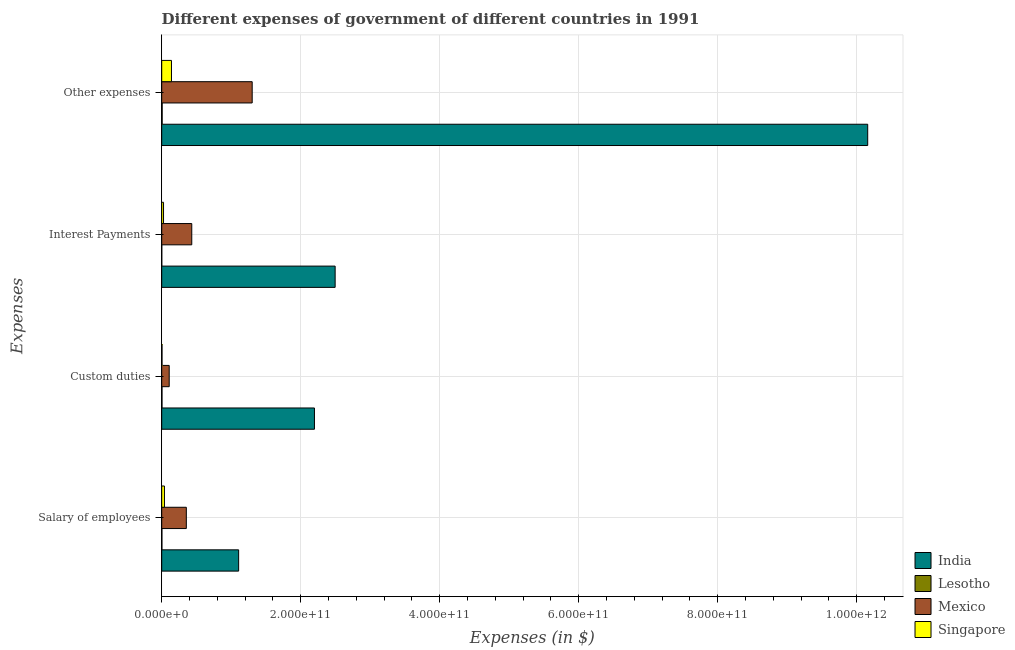How many different coloured bars are there?
Your answer should be compact. 4. How many groups of bars are there?
Your answer should be very brief. 4. Are the number of bars on each tick of the Y-axis equal?
Keep it short and to the point. Yes. What is the label of the 3rd group of bars from the top?
Offer a very short reply. Custom duties. What is the amount spent on other expenses in Singapore?
Provide a succinct answer. 1.40e+1. Across all countries, what is the maximum amount spent on custom duties?
Provide a succinct answer. 2.20e+11. Across all countries, what is the minimum amount spent on salary of employees?
Offer a terse response. 2.81e+08. In which country was the amount spent on other expenses maximum?
Your response must be concise. India. In which country was the amount spent on custom duties minimum?
Make the answer very short. Lesotho. What is the total amount spent on custom duties in the graph?
Make the answer very short. 2.31e+11. What is the difference between the amount spent on interest payments in Singapore and that in Mexico?
Make the answer very short. -4.06e+1. What is the difference between the amount spent on custom duties in India and the amount spent on other expenses in Lesotho?
Offer a very short reply. 2.19e+11. What is the average amount spent on custom duties per country?
Make the answer very short. 5.79e+1. What is the difference between the amount spent on other expenses and amount spent on salary of employees in Lesotho?
Give a very brief answer. 3.55e+08. What is the ratio of the amount spent on interest payments in India to that in Singapore?
Make the answer very short. 94.92. Is the amount spent on other expenses in Mexico less than that in Singapore?
Your response must be concise. No. What is the difference between the highest and the second highest amount spent on interest payments?
Your response must be concise. 2.06e+11. What is the difference between the highest and the lowest amount spent on other expenses?
Make the answer very short. 1.02e+12. Is it the case that in every country, the sum of the amount spent on other expenses and amount spent on custom duties is greater than the sum of amount spent on salary of employees and amount spent on interest payments?
Ensure brevity in your answer.  No. What does the 2nd bar from the top in Custom duties represents?
Offer a terse response. Mexico. What does the 2nd bar from the bottom in Salary of employees represents?
Offer a terse response. Lesotho. What is the difference between two consecutive major ticks on the X-axis?
Your response must be concise. 2.00e+11. Does the graph contain grids?
Provide a short and direct response. Yes. How are the legend labels stacked?
Provide a succinct answer. Vertical. What is the title of the graph?
Keep it short and to the point. Different expenses of government of different countries in 1991. What is the label or title of the X-axis?
Offer a very short reply. Expenses (in $). What is the label or title of the Y-axis?
Your answer should be compact. Expenses. What is the Expenses (in $) of India in Salary of employees?
Keep it short and to the point. 1.11e+11. What is the Expenses (in $) in Lesotho in Salary of employees?
Provide a succinct answer. 2.81e+08. What is the Expenses (in $) in Mexico in Salary of employees?
Your answer should be very brief. 3.54e+1. What is the Expenses (in $) in Singapore in Salary of employees?
Give a very brief answer. 3.95e+09. What is the Expenses (in $) in India in Custom duties?
Your answer should be very brief. 2.20e+11. What is the Expenses (in $) in Lesotho in Custom duties?
Provide a succinct answer. 4.24e+08. What is the Expenses (in $) of Mexico in Custom duties?
Your response must be concise. 1.08e+1. What is the Expenses (in $) in Singapore in Custom duties?
Provide a short and direct response. 4.33e+08. What is the Expenses (in $) of India in Interest Payments?
Provide a succinct answer. 2.50e+11. What is the Expenses (in $) of Lesotho in Interest Payments?
Give a very brief answer. 8.45e+07. What is the Expenses (in $) in Mexico in Interest Payments?
Ensure brevity in your answer.  4.32e+1. What is the Expenses (in $) in Singapore in Interest Payments?
Keep it short and to the point. 2.63e+09. What is the Expenses (in $) of India in Other expenses?
Your answer should be very brief. 1.02e+12. What is the Expenses (in $) in Lesotho in Other expenses?
Provide a succinct answer. 6.37e+08. What is the Expenses (in $) in Mexico in Other expenses?
Make the answer very short. 1.30e+11. What is the Expenses (in $) in Singapore in Other expenses?
Make the answer very short. 1.40e+1. Across all Expenses, what is the maximum Expenses (in $) of India?
Provide a succinct answer. 1.02e+12. Across all Expenses, what is the maximum Expenses (in $) of Lesotho?
Your answer should be compact. 6.37e+08. Across all Expenses, what is the maximum Expenses (in $) in Mexico?
Your response must be concise. 1.30e+11. Across all Expenses, what is the maximum Expenses (in $) of Singapore?
Ensure brevity in your answer.  1.40e+1. Across all Expenses, what is the minimum Expenses (in $) of India?
Offer a terse response. 1.11e+11. Across all Expenses, what is the minimum Expenses (in $) in Lesotho?
Offer a terse response. 8.45e+07. Across all Expenses, what is the minimum Expenses (in $) in Mexico?
Ensure brevity in your answer.  1.08e+1. Across all Expenses, what is the minimum Expenses (in $) of Singapore?
Make the answer very short. 4.33e+08. What is the total Expenses (in $) of India in the graph?
Offer a terse response. 1.60e+12. What is the total Expenses (in $) of Lesotho in the graph?
Offer a terse response. 1.43e+09. What is the total Expenses (in $) in Mexico in the graph?
Offer a terse response. 2.20e+11. What is the total Expenses (in $) of Singapore in the graph?
Keep it short and to the point. 2.11e+1. What is the difference between the Expenses (in $) of India in Salary of employees and that in Custom duties?
Keep it short and to the point. -1.09e+11. What is the difference between the Expenses (in $) of Lesotho in Salary of employees and that in Custom duties?
Your response must be concise. -1.43e+08. What is the difference between the Expenses (in $) in Mexico in Salary of employees and that in Custom duties?
Offer a terse response. 2.46e+1. What is the difference between the Expenses (in $) in Singapore in Salary of employees and that in Custom duties?
Ensure brevity in your answer.  3.52e+09. What is the difference between the Expenses (in $) of India in Salary of employees and that in Interest Payments?
Offer a terse response. -1.39e+11. What is the difference between the Expenses (in $) in Lesotho in Salary of employees and that in Interest Payments?
Offer a terse response. 1.97e+08. What is the difference between the Expenses (in $) of Mexico in Salary of employees and that in Interest Payments?
Make the answer very short. -7.83e+09. What is the difference between the Expenses (in $) of Singapore in Salary of employees and that in Interest Payments?
Your response must be concise. 1.32e+09. What is the difference between the Expenses (in $) in India in Salary of employees and that in Other expenses?
Your answer should be compact. -9.05e+11. What is the difference between the Expenses (in $) of Lesotho in Salary of employees and that in Other expenses?
Provide a succinct answer. -3.55e+08. What is the difference between the Expenses (in $) of Mexico in Salary of employees and that in Other expenses?
Provide a short and direct response. -9.48e+1. What is the difference between the Expenses (in $) of Singapore in Salary of employees and that in Other expenses?
Your answer should be compact. -1.01e+1. What is the difference between the Expenses (in $) in India in Custom duties and that in Interest Payments?
Ensure brevity in your answer.  -2.98e+1. What is the difference between the Expenses (in $) in Lesotho in Custom duties and that in Interest Payments?
Provide a succinct answer. 3.40e+08. What is the difference between the Expenses (in $) of Mexico in Custom duties and that in Interest Payments?
Provide a succinct answer. -3.25e+1. What is the difference between the Expenses (in $) in Singapore in Custom duties and that in Interest Payments?
Ensure brevity in your answer.  -2.20e+09. What is the difference between the Expenses (in $) in India in Custom duties and that in Other expenses?
Your response must be concise. -7.96e+11. What is the difference between the Expenses (in $) in Lesotho in Custom duties and that in Other expenses?
Your answer should be compact. -2.13e+08. What is the difference between the Expenses (in $) of Mexico in Custom duties and that in Other expenses?
Provide a short and direct response. -1.19e+11. What is the difference between the Expenses (in $) of Singapore in Custom duties and that in Other expenses?
Your answer should be very brief. -1.36e+1. What is the difference between the Expenses (in $) in India in Interest Payments and that in Other expenses?
Ensure brevity in your answer.  -7.66e+11. What is the difference between the Expenses (in $) of Lesotho in Interest Payments and that in Other expenses?
Offer a very short reply. -5.52e+08. What is the difference between the Expenses (in $) of Mexico in Interest Payments and that in Other expenses?
Ensure brevity in your answer.  -8.69e+1. What is the difference between the Expenses (in $) in Singapore in Interest Payments and that in Other expenses?
Keep it short and to the point. -1.14e+1. What is the difference between the Expenses (in $) in India in Salary of employees and the Expenses (in $) in Lesotho in Custom duties?
Keep it short and to the point. 1.10e+11. What is the difference between the Expenses (in $) in India in Salary of employees and the Expenses (in $) in Mexico in Custom duties?
Your answer should be very brief. 9.99e+1. What is the difference between the Expenses (in $) of India in Salary of employees and the Expenses (in $) of Singapore in Custom duties?
Make the answer very short. 1.10e+11. What is the difference between the Expenses (in $) in Lesotho in Salary of employees and the Expenses (in $) in Mexico in Custom duties?
Keep it short and to the point. -1.05e+1. What is the difference between the Expenses (in $) of Lesotho in Salary of employees and the Expenses (in $) of Singapore in Custom duties?
Give a very brief answer. -1.52e+08. What is the difference between the Expenses (in $) of Mexico in Salary of employees and the Expenses (in $) of Singapore in Custom duties?
Offer a terse response. 3.50e+1. What is the difference between the Expenses (in $) in India in Salary of employees and the Expenses (in $) in Lesotho in Interest Payments?
Provide a succinct answer. 1.11e+11. What is the difference between the Expenses (in $) of India in Salary of employees and the Expenses (in $) of Mexico in Interest Payments?
Your answer should be very brief. 6.74e+1. What is the difference between the Expenses (in $) in India in Salary of employees and the Expenses (in $) in Singapore in Interest Payments?
Your response must be concise. 1.08e+11. What is the difference between the Expenses (in $) in Lesotho in Salary of employees and the Expenses (in $) in Mexico in Interest Payments?
Offer a terse response. -4.30e+1. What is the difference between the Expenses (in $) of Lesotho in Salary of employees and the Expenses (in $) of Singapore in Interest Payments?
Give a very brief answer. -2.35e+09. What is the difference between the Expenses (in $) of Mexico in Salary of employees and the Expenses (in $) of Singapore in Interest Payments?
Make the answer very short. 3.28e+1. What is the difference between the Expenses (in $) in India in Salary of employees and the Expenses (in $) in Lesotho in Other expenses?
Your response must be concise. 1.10e+11. What is the difference between the Expenses (in $) of India in Salary of employees and the Expenses (in $) of Mexico in Other expenses?
Provide a short and direct response. -1.95e+1. What is the difference between the Expenses (in $) in India in Salary of employees and the Expenses (in $) in Singapore in Other expenses?
Keep it short and to the point. 9.66e+1. What is the difference between the Expenses (in $) in Lesotho in Salary of employees and the Expenses (in $) in Mexico in Other expenses?
Provide a short and direct response. -1.30e+11. What is the difference between the Expenses (in $) in Lesotho in Salary of employees and the Expenses (in $) in Singapore in Other expenses?
Your answer should be compact. -1.38e+1. What is the difference between the Expenses (in $) in Mexico in Salary of employees and the Expenses (in $) in Singapore in Other expenses?
Give a very brief answer. 2.14e+1. What is the difference between the Expenses (in $) in India in Custom duties and the Expenses (in $) in Lesotho in Interest Payments?
Offer a very short reply. 2.20e+11. What is the difference between the Expenses (in $) of India in Custom duties and the Expenses (in $) of Mexico in Interest Payments?
Provide a short and direct response. 1.77e+11. What is the difference between the Expenses (in $) in India in Custom duties and the Expenses (in $) in Singapore in Interest Payments?
Your answer should be very brief. 2.17e+11. What is the difference between the Expenses (in $) of Lesotho in Custom duties and the Expenses (in $) of Mexico in Interest Payments?
Your answer should be very brief. -4.28e+1. What is the difference between the Expenses (in $) of Lesotho in Custom duties and the Expenses (in $) of Singapore in Interest Payments?
Your answer should be very brief. -2.20e+09. What is the difference between the Expenses (in $) of Mexico in Custom duties and the Expenses (in $) of Singapore in Interest Payments?
Provide a short and direct response. 8.14e+09. What is the difference between the Expenses (in $) in India in Custom duties and the Expenses (in $) in Lesotho in Other expenses?
Keep it short and to the point. 2.19e+11. What is the difference between the Expenses (in $) of India in Custom duties and the Expenses (in $) of Mexico in Other expenses?
Ensure brevity in your answer.  8.96e+1. What is the difference between the Expenses (in $) in India in Custom duties and the Expenses (in $) in Singapore in Other expenses?
Keep it short and to the point. 2.06e+11. What is the difference between the Expenses (in $) in Lesotho in Custom duties and the Expenses (in $) in Mexico in Other expenses?
Your answer should be compact. -1.30e+11. What is the difference between the Expenses (in $) in Lesotho in Custom duties and the Expenses (in $) in Singapore in Other expenses?
Your answer should be compact. -1.36e+1. What is the difference between the Expenses (in $) in Mexico in Custom duties and the Expenses (in $) in Singapore in Other expenses?
Keep it short and to the point. -3.27e+09. What is the difference between the Expenses (in $) in India in Interest Payments and the Expenses (in $) in Lesotho in Other expenses?
Provide a succinct answer. 2.49e+11. What is the difference between the Expenses (in $) in India in Interest Payments and the Expenses (in $) in Mexico in Other expenses?
Keep it short and to the point. 1.19e+11. What is the difference between the Expenses (in $) in India in Interest Payments and the Expenses (in $) in Singapore in Other expenses?
Give a very brief answer. 2.36e+11. What is the difference between the Expenses (in $) in Lesotho in Interest Payments and the Expenses (in $) in Mexico in Other expenses?
Offer a terse response. -1.30e+11. What is the difference between the Expenses (in $) of Lesotho in Interest Payments and the Expenses (in $) of Singapore in Other expenses?
Offer a very short reply. -1.40e+1. What is the difference between the Expenses (in $) in Mexico in Interest Payments and the Expenses (in $) in Singapore in Other expenses?
Your answer should be compact. 2.92e+1. What is the average Expenses (in $) of India per Expenses?
Your answer should be compact. 3.99e+11. What is the average Expenses (in $) in Lesotho per Expenses?
Your answer should be very brief. 3.57e+08. What is the average Expenses (in $) of Mexico per Expenses?
Keep it short and to the point. 5.49e+1. What is the average Expenses (in $) of Singapore per Expenses?
Your answer should be very brief. 5.26e+09. What is the difference between the Expenses (in $) in India and Expenses (in $) in Lesotho in Salary of employees?
Give a very brief answer. 1.10e+11. What is the difference between the Expenses (in $) of India and Expenses (in $) of Mexico in Salary of employees?
Offer a terse response. 7.53e+1. What is the difference between the Expenses (in $) in India and Expenses (in $) in Singapore in Salary of employees?
Your response must be concise. 1.07e+11. What is the difference between the Expenses (in $) in Lesotho and Expenses (in $) in Mexico in Salary of employees?
Offer a very short reply. -3.51e+1. What is the difference between the Expenses (in $) of Lesotho and Expenses (in $) of Singapore in Salary of employees?
Your answer should be very brief. -3.67e+09. What is the difference between the Expenses (in $) in Mexico and Expenses (in $) in Singapore in Salary of employees?
Your answer should be very brief. 3.15e+1. What is the difference between the Expenses (in $) of India and Expenses (in $) of Lesotho in Custom duties?
Offer a terse response. 2.19e+11. What is the difference between the Expenses (in $) in India and Expenses (in $) in Mexico in Custom duties?
Give a very brief answer. 2.09e+11. What is the difference between the Expenses (in $) in India and Expenses (in $) in Singapore in Custom duties?
Your response must be concise. 2.19e+11. What is the difference between the Expenses (in $) of Lesotho and Expenses (in $) of Mexico in Custom duties?
Offer a very short reply. -1.03e+1. What is the difference between the Expenses (in $) of Lesotho and Expenses (in $) of Singapore in Custom duties?
Your answer should be very brief. -9.00e+06. What is the difference between the Expenses (in $) in Mexico and Expenses (in $) in Singapore in Custom duties?
Your answer should be very brief. 1.03e+1. What is the difference between the Expenses (in $) in India and Expenses (in $) in Lesotho in Interest Payments?
Your response must be concise. 2.49e+11. What is the difference between the Expenses (in $) in India and Expenses (in $) in Mexico in Interest Payments?
Provide a short and direct response. 2.06e+11. What is the difference between the Expenses (in $) in India and Expenses (in $) in Singapore in Interest Payments?
Make the answer very short. 2.47e+11. What is the difference between the Expenses (in $) of Lesotho and Expenses (in $) of Mexico in Interest Payments?
Provide a short and direct response. -4.32e+1. What is the difference between the Expenses (in $) in Lesotho and Expenses (in $) in Singapore in Interest Payments?
Keep it short and to the point. -2.54e+09. What is the difference between the Expenses (in $) in Mexico and Expenses (in $) in Singapore in Interest Payments?
Keep it short and to the point. 4.06e+1. What is the difference between the Expenses (in $) in India and Expenses (in $) in Lesotho in Other expenses?
Ensure brevity in your answer.  1.02e+12. What is the difference between the Expenses (in $) of India and Expenses (in $) of Mexico in Other expenses?
Offer a terse response. 8.86e+11. What is the difference between the Expenses (in $) of India and Expenses (in $) of Singapore in Other expenses?
Your answer should be very brief. 1.00e+12. What is the difference between the Expenses (in $) of Lesotho and Expenses (in $) of Mexico in Other expenses?
Your answer should be very brief. -1.30e+11. What is the difference between the Expenses (in $) of Lesotho and Expenses (in $) of Singapore in Other expenses?
Offer a very short reply. -1.34e+1. What is the difference between the Expenses (in $) of Mexico and Expenses (in $) of Singapore in Other expenses?
Provide a succinct answer. 1.16e+11. What is the ratio of the Expenses (in $) in India in Salary of employees to that in Custom duties?
Provide a succinct answer. 0.5. What is the ratio of the Expenses (in $) in Lesotho in Salary of employees to that in Custom duties?
Your answer should be compact. 0.66. What is the ratio of the Expenses (in $) of Mexico in Salary of employees to that in Custom duties?
Ensure brevity in your answer.  3.29. What is the ratio of the Expenses (in $) in Singapore in Salary of employees to that in Custom duties?
Keep it short and to the point. 9.12. What is the ratio of the Expenses (in $) in India in Salary of employees to that in Interest Payments?
Provide a short and direct response. 0.44. What is the ratio of the Expenses (in $) in Lesotho in Salary of employees to that in Interest Payments?
Your answer should be very brief. 3.33. What is the ratio of the Expenses (in $) of Mexico in Salary of employees to that in Interest Payments?
Provide a succinct answer. 0.82. What is the ratio of the Expenses (in $) in Singapore in Salary of employees to that in Interest Payments?
Your answer should be compact. 1.5. What is the ratio of the Expenses (in $) of India in Salary of employees to that in Other expenses?
Provide a succinct answer. 0.11. What is the ratio of the Expenses (in $) in Lesotho in Salary of employees to that in Other expenses?
Keep it short and to the point. 0.44. What is the ratio of the Expenses (in $) in Mexico in Salary of employees to that in Other expenses?
Give a very brief answer. 0.27. What is the ratio of the Expenses (in $) of Singapore in Salary of employees to that in Other expenses?
Provide a succinct answer. 0.28. What is the ratio of the Expenses (in $) in India in Custom duties to that in Interest Payments?
Give a very brief answer. 0.88. What is the ratio of the Expenses (in $) in Lesotho in Custom duties to that in Interest Payments?
Your answer should be very brief. 5.02. What is the ratio of the Expenses (in $) of Mexico in Custom duties to that in Interest Payments?
Your response must be concise. 0.25. What is the ratio of the Expenses (in $) of Singapore in Custom duties to that in Interest Payments?
Ensure brevity in your answer.  0.16. What is the ratio of the Expenses (in $) in India in Custom duties to that in Other expenses?
Your answer should be compact. 0.22. What is the ratio of the Expenses (in $) of Lesotho in Custom duties to that in Other expenses?
Offer a very short reply. 0.67. What is the ratio of the Expenses (in $) of Mexico in Custom duties to that in Other expenses?
Your answer should be very brief. 0.08. What is the ratio of the Expenses (in $) of Singapore in Custom duties to that in Other expenses?
Ensure brevity in your answer.  0.03. What is the ratio of the Expenses (in $) in India in Interest Payments to that in Other expenses?
Make the answer very short. 0.25. What is the ratio of the Expenses (in $) in Lesotho in Interest Payments to that in Other expenses?
Make the answer very short. 0.13. What is the ratio of the Expenses (in $) in Mexico in Interest Payments to that in Other expenses?
Your answer should be compact. 0.33. What is the ratio of the Expenses (in $) in Singapore in Interest Payments to that in Other expenses?
Ensure brevity in your answer.  0.19. What is the difference between the highest and the second highest Expenses (in $) in India?
Make the answer very short. 7.66e+11. What is the difference between the highest and the second highest Expenses (in $) of Lesotho?
Offer a terse response. 2.13e+08. What is the difference between the highest and the second highest Expenses (in $) in Mexico?
Make the answer very short. 8.69e+1. What is the difference between the highest and the second highest Expenses (in $) in Singapore?
Offer a terse response. 1.01e+1. What is the difference between the highest and the lowest Expenses (in $) in India?
Give a very brief answer. 9.05e+11. What is the difference between the highest and the lowest Expenses (in $) in Lesotho?
Offer a very short reply. 5.52e+08. What is the difference between the highest and the lowest Expenses (in $) of Mexico?
Your answer should be very brief. 1.19e+11. What is the difference between the highest and the lowest Expenses (in $) in Singapore?
Give a very brief answer. 1.36e+1. 